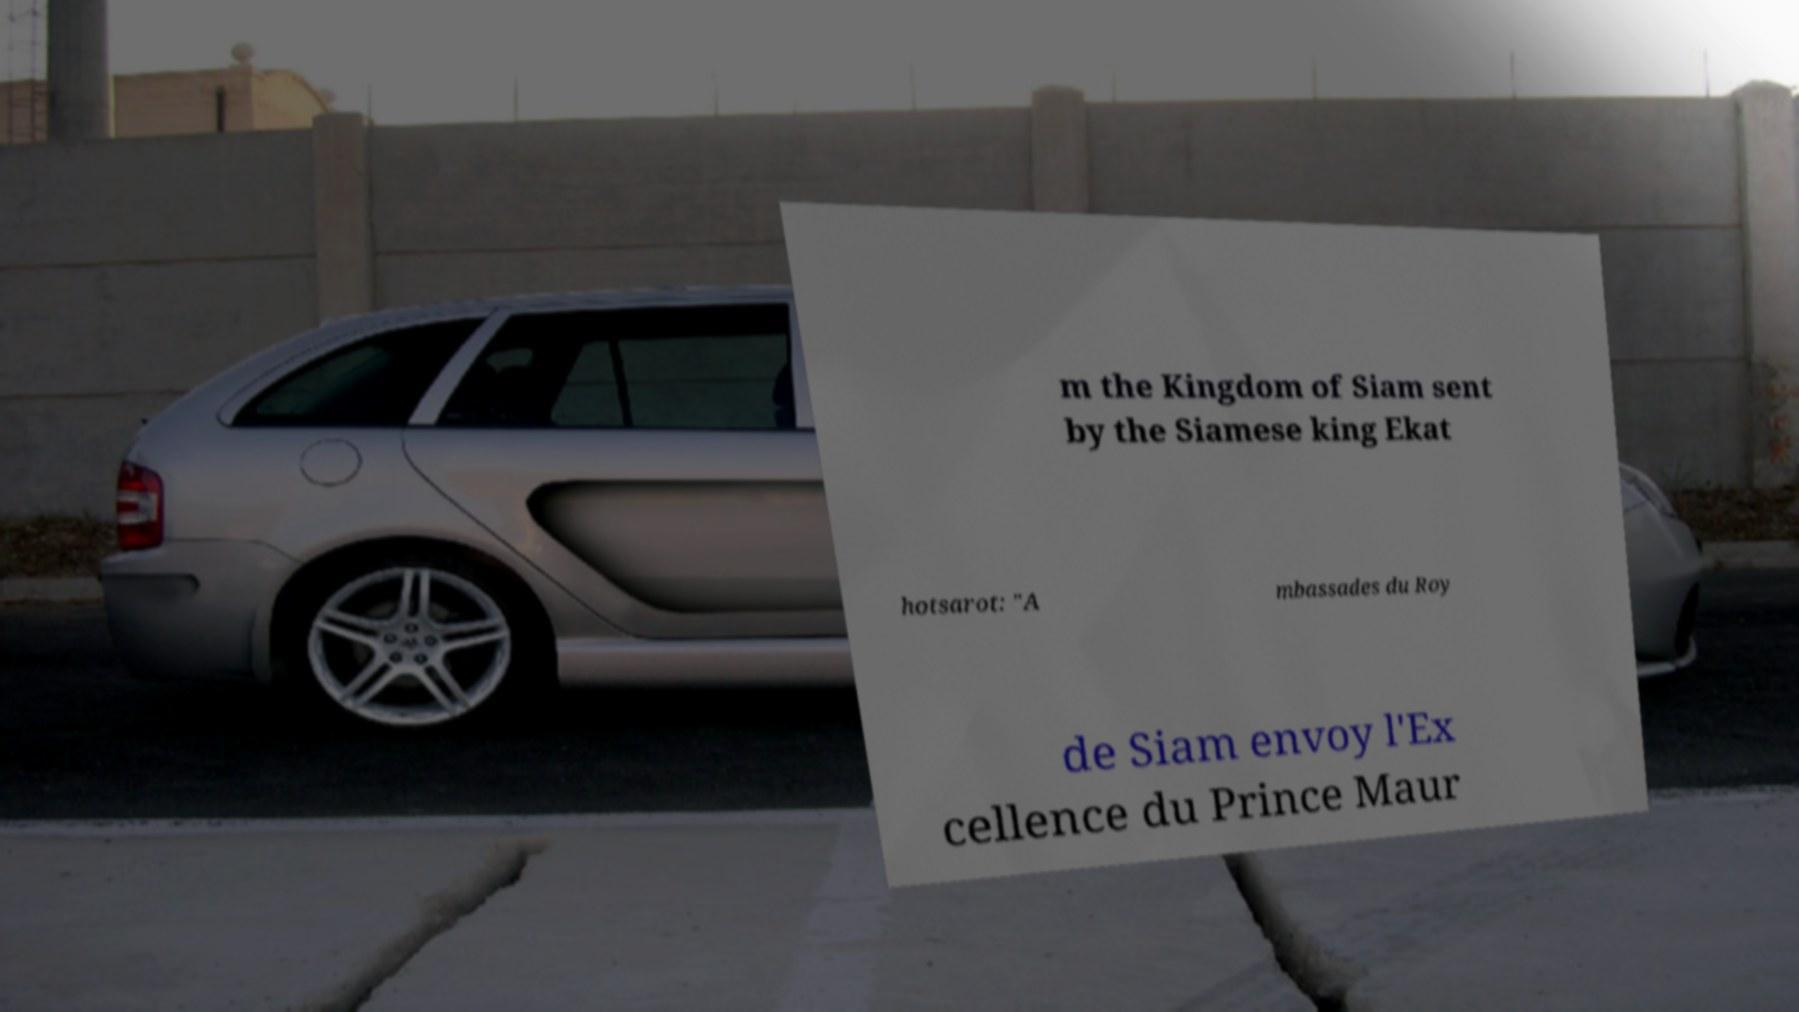I need the written content from this picture converted into text. Can you do that? m the Kingdom of Siam sent by the Siamese king Ekat hotsarot: "A mbassades du Roy de Siam envoy l'Ex cellence du Prince Maur 